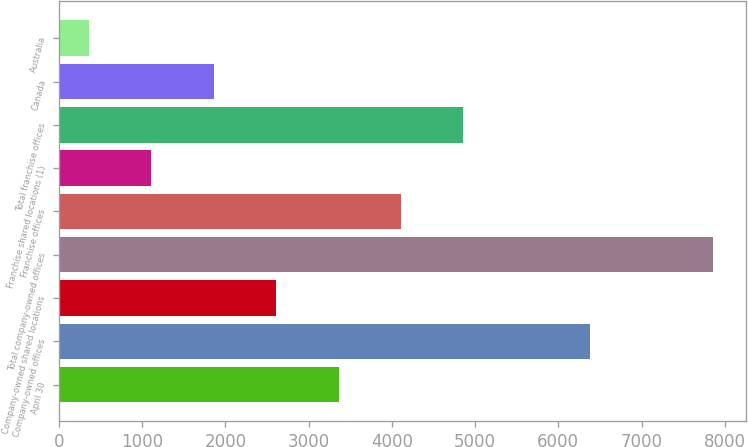Convert chart. <chart><loc_0><loc_0><loc_500><loc_500><bar_chart><fcel>April 30<fcel>Company-owned offices<fcel>Company-owned shared locations<fcel>Total company-owned offices<fcel>Franchise offices<fcel>Franchise shared locations (1)<fcel>Total franchise offices<fcel>Canada<fcel>Australia<nl><fcel>3361.2<fcel>6387<fcel>2611.4<fcel>7860<fcel>4111<fcel>1111.8<fcel>4860.8<fcel>1861.6<fcel>362<nl></chart> 